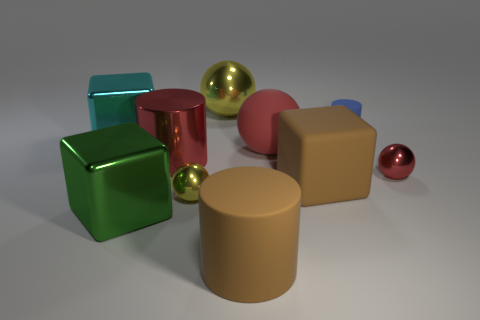Subtract 1 spheres. How many spheres are left? 3 Subtract all cubes. How many objects are left? 7 Subtract all small rubber things. Subtract all tiny red metal things. How many objects are left? 8 Add 6 big brown cylinders. How many big brown cylinders are left? 7 Add 7 red shiny objects. How many red shiny objects exist? 9 Subtract 0 gray cylinders. How many objects are left? 10 